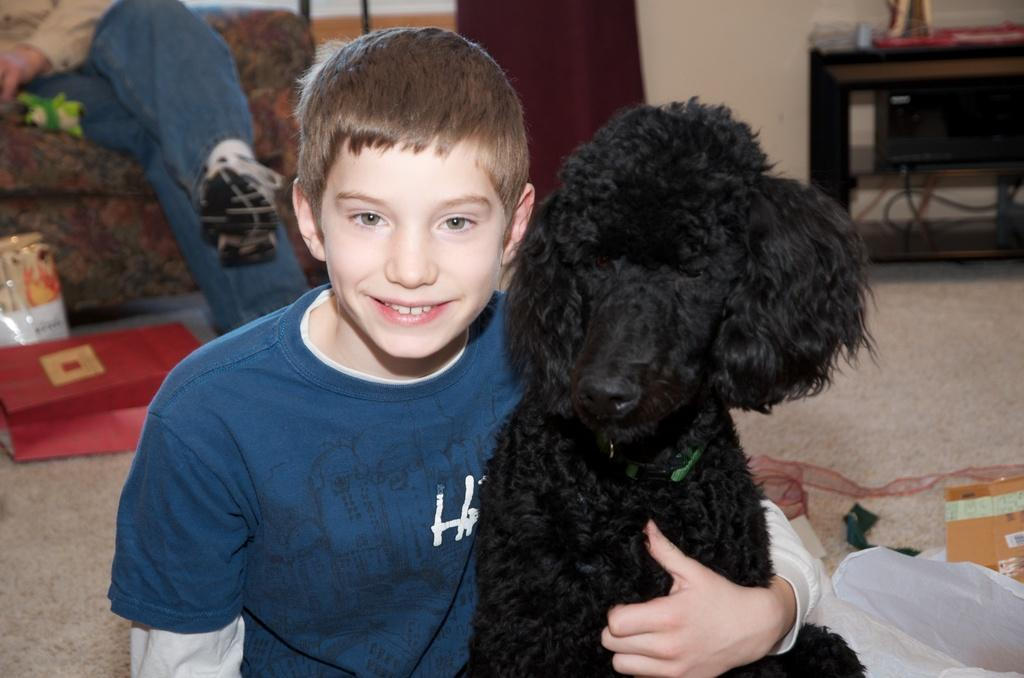What is the boy in the image doing? The boy is sitting on the floor in the image. What is the boy holding in the image? The boy is holding a dog in the image. Can you describe the person in the background of the image? There is a person sitting on a couch in the background of the image. What can be seen on the wall in the image? There is a wall visible in the image. What type of furniture is present in the image? There is a cupboard in the image. What type of eggs can be seen in the caption of the image? There is no caption present in the image, and therefore no eggs can be seen in the caption. 